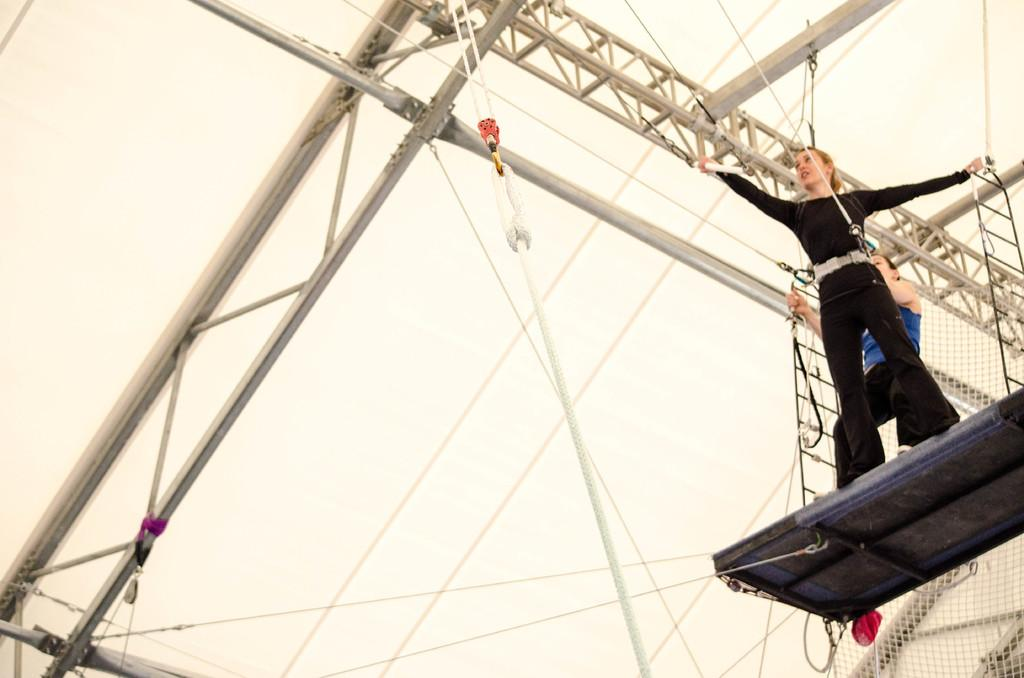How many people are in the image? There are two people in the image. What are the people doing in the image? The people are standing on an object. Can you describe the object the people are standing on? The object is attached to a metal structure. What else can be seen in the image besides the people and the object? There is a net in the image. What is visible in the background of the image? The sky is visible in the background of the image. Who is the parent of the crow in the image? There is no crow present in the image, so it is not possible to determine the parent of a crow. Who is the creator of the metal structure in the image? The creator of the metal structure is not mentioned in the image, so it is not possible to determine who the creator is. 